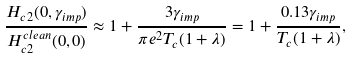Convert formula to latex. <formula><loc_0><loc_0><loc_500><loc_500>\frac { H _ { c 2 } ( 0 , \gamma _ { i m p } ) } { H _ { c 2 } ^ { c l e a n } ( 0 , 0 ) } \approx 1 + \frac { 3 \gamma _ { i m p } } { \pi e ^ { 2 } T _ { c } ( 1 + \lambda ) } = 1 + \frac { 0 . 1 3 \gamma _ { i m p } } { T _ { c } ( 1 + \lambda ) } ,</formula> 